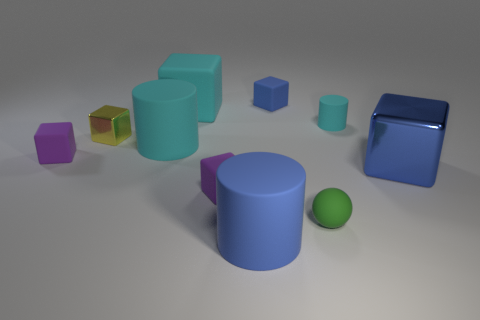Subtract all small matte cylinders. How many cylinders are left? 2 Subtract 3 cylinders. How many cylinders are left? 0 Subtract all balls. How many objects are left? 9 Subtract all gray balls. How many cyan cylinders are left? 2 Subtract all cyan cylinders. How many cylinders are left? 1 Subtract all cyan cylinders. Subtract all red cubes. How many cylinders are left? 1 Subtract all gray objects. Subtract all large blue matte cylinders. How many objects are left? 9 Add 3 small metal objects. How many small metal objects are left? 4 Add 1 yellow metallic objects. How many yellow metallic objects exist? 2 Subtract 1 yellow blocks. How many objects are left? 9 